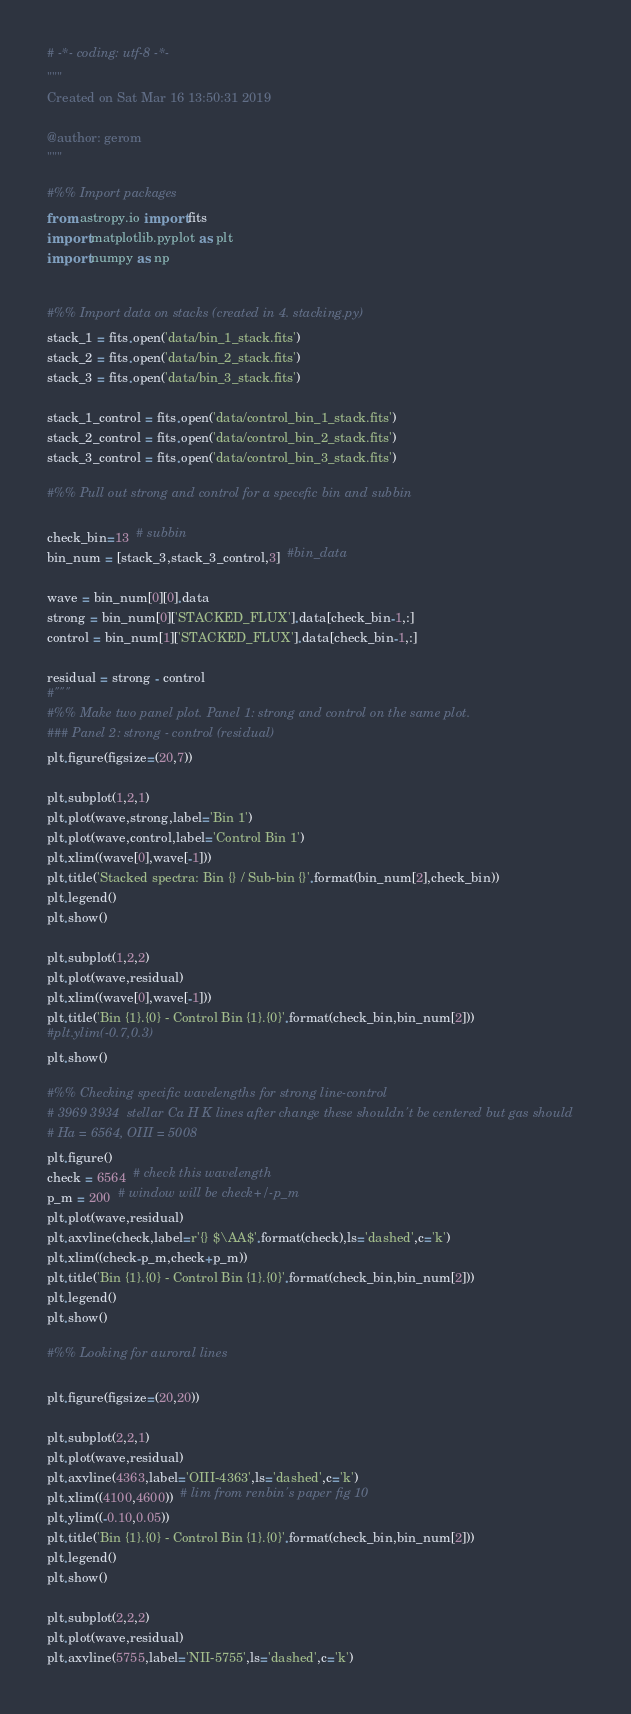<code> <loc_0><loc_0><loc_500><loc_500><_Python_># -*- coding: utf-8 -*-
"""
Created on Sat Mar 16 13:50:31 2019

@author: gerom
"""

#%% Import packages
from astropy.io import fits
import matplotlib.pyplot as plt
import numpy as np


#%% Import data on stacks (created in 4. stacking.py)
stack_1 = fits.open('data/bin_1_stack.fits')
stack_2 = fits.open('data/bin_2_stack.fits')
stack_3 = fits.open('data/bin_3_stack.fits')

stack_1_control = fits.open('data/control_bin_1_stack.fits')
stack_2_control = fits.open('data/control_bin_2_stack.fits')
stack_3_control = fits.open('data/control_bin_3_stack.fits')

#%% Pull out strong and control for a specefic bin and subbin

check_bin=13  # subbin
bin_num = [stack_3,stack_3_control,3]  #bin_data

wave = bin_num[0][0].data
strong = bin_num[0]['STACKED_FLUX'].data[check_bin-1,:]
control = bin_num[1]['STACKED_FLUX'].data[check_bin-1,:]

residual = strong - control
#"""
#%% Make two panel plot. Panel 1: strong and control on the same plot. 
### Panel 2: strong - control (residual)
plt.figure(figsize=(20,7))

plt.subplot(1,2,1)
plt.plot(wave,strong,label='Bin 1')
plt.plot(wave,control,label='Control Bin 1')
plt.xlim((wave[0],wave[-1]))
plt.title('Stacked spectra: Bin {} / Sub-bin {}'.format(bin_num[2],check_bin))
plt.legend()
plt.show()

plt.subplot(1,2,2)
plt.plot(wave,residual)
plt.xlim((wave[0],wave[-1]))
plt.title('Bin {1}.{0} - Control Bin {1}.{0}'.format(check_bin,bin_num[2]))
#plt.ylim(-0.7,0.3)
plt.show()

#%% Checking specific wavelengths for strong line-control
# 3969 3934  stellar Ca H K lines after change these shouldn't be centered but gas should
# Ha = 6564, OIII = 5008
plt.figure()
check = 6564  # check this wavelength
p_m = 200  # window will be check+/-p_m
plt.plot(wave,residual)
plt.axvline(check,label=r'{} $\AA$'.format(check),ls='dashed',c='k')
plt.xlim((check-p_m,check+p_m))  
plt.title('Bin {1}.{0} - Control Bin {1}.{0}'.format(check_bin,bin_num[2]))
plt.legend()
plt.show()

#%% Looking for auroral lines

plt.figure(figsize=(20,20))

plt.subplot(2,2,1)
plt.plot(wave,residual)
plt.axvline(4363,label='OIII-4363',ls='dashed',c='k')
plt.xlim((4100,4600))  # lim from renbin's paper fig 10
plt.ylim((-0.10,0.05))
plt.title('Bin {1}.{0} - Control Bin {1}.{0}'.format(check_bin,bin_num[2]))
plt.legend()
plt.show()

plt.subplot(2,2,2)
plt.plot(wave,residual)
plt.axvline(5755,label='NII-5755',ls='dashed',c='k')</code> 